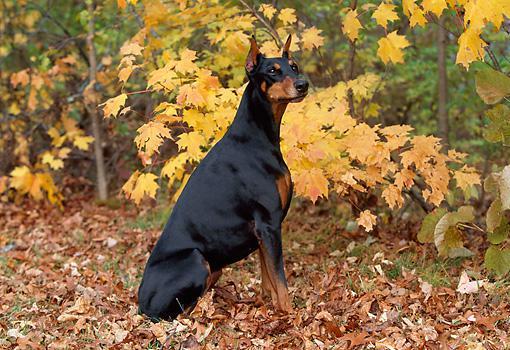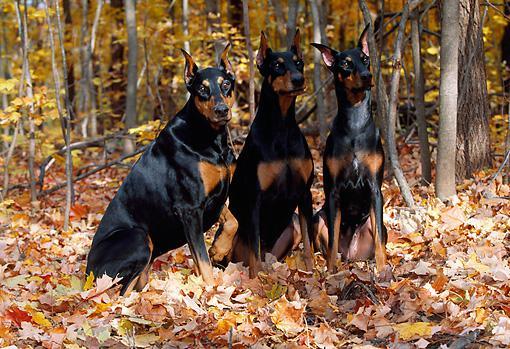The first image is the image on the left, the second image is the image on the right. For the images displayed, is the sentence "At least one image features a doberman sitting upright in autumn foliage, and all dobermans are in some pose on autumn foilage." factually correct? Answer yes or no. Yes. The first image is the image on the left, the second image is the image on the right. Considering the images on both sides, is "The dogs are all sitting in leaves." valid? Answer yes or no. Yes. 